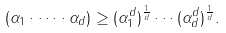Convert formula to latex. <formula><loc_0><loc_0><loc_500><loc_500>( \alpha _ { 1 } \cdot \dots \cdot \alpha _ { d } ) \geq ( \alpha _ { 1 } ^ { d } ) ^ { \frac { 1 } { d } } \cdots ( \alpha _ { d } ^ { d } ) ^ { \frac { 1 } { d } } .</formula> 